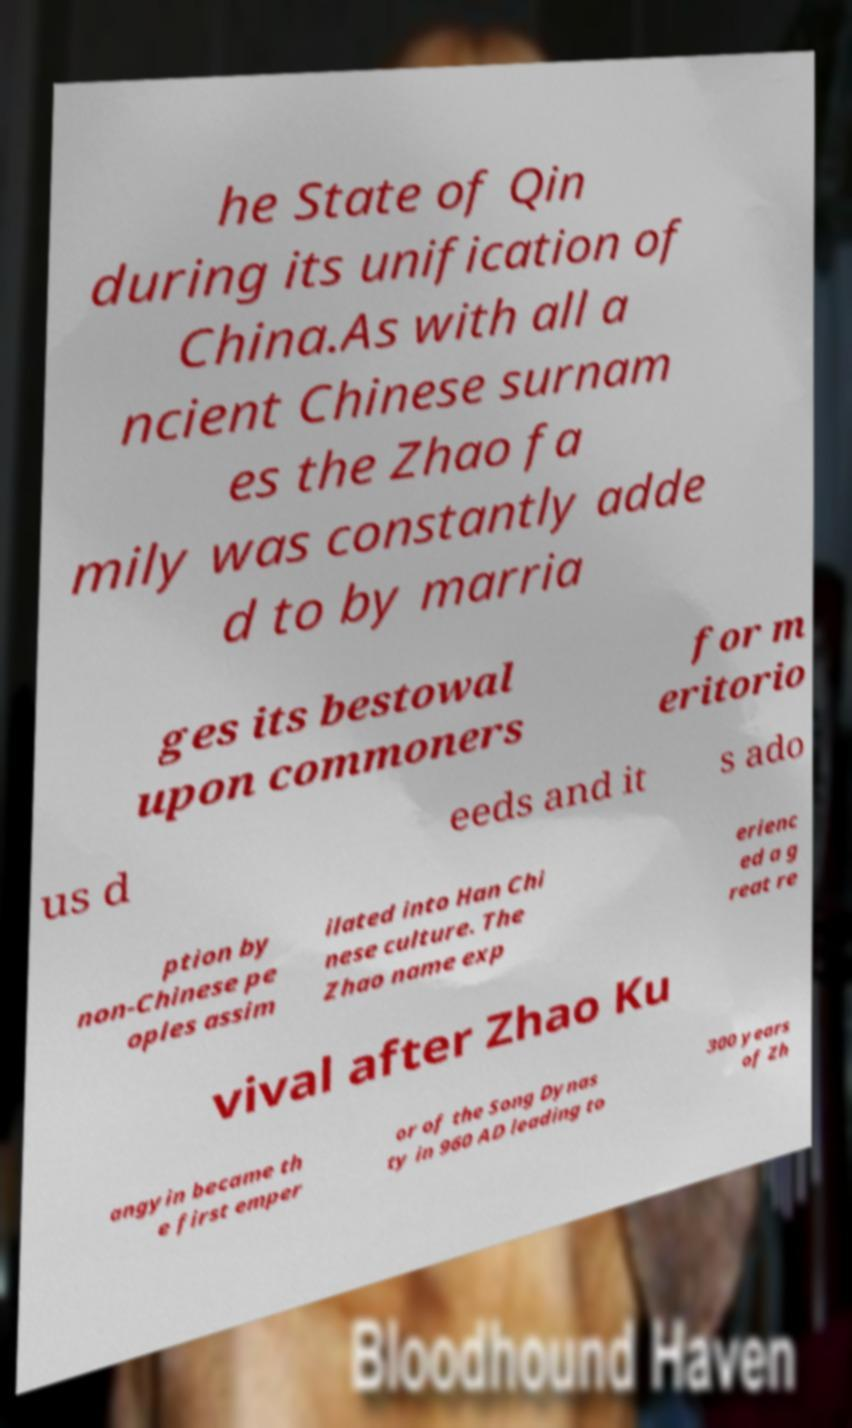For documentation purposes, I need the text within this image transcribed. Could you provide that? he State of Qin during its unification of China.As with all a ncient Chinese surnam es the Zhao fa mily was constantly adde d to by marria ges its bestowal upon commoners for m eritorio us d eeds and it s ado ption by non-Chinese pe oples assim ilated into Han Chi nese culture. The Zhao name exp erienc ed a g reat re vival after Zhao Ku angyin became th e first emper or of the Song Dynas ty in 960 AD leading to 300 years of Zh 